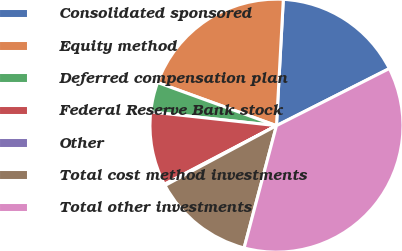Convert chart to OTSL. <chart><loc_0><loc_0><loc_500><loc_500><pie_chart><fcel>Consolidated sponsored<fcel>Equity method<fcel>Deferred compensation plan<fcel>Federal Reserve Bank stock<fcel>Other<fcel>Total cost method investments<fcel>Total other investments<nl><fcel>16.68%<fcel>20.32%<fcel>3.81%<fcel>9.4%<fcel>0.17%<fcel>13.04%<fcel>36.57%<nl></chart> 